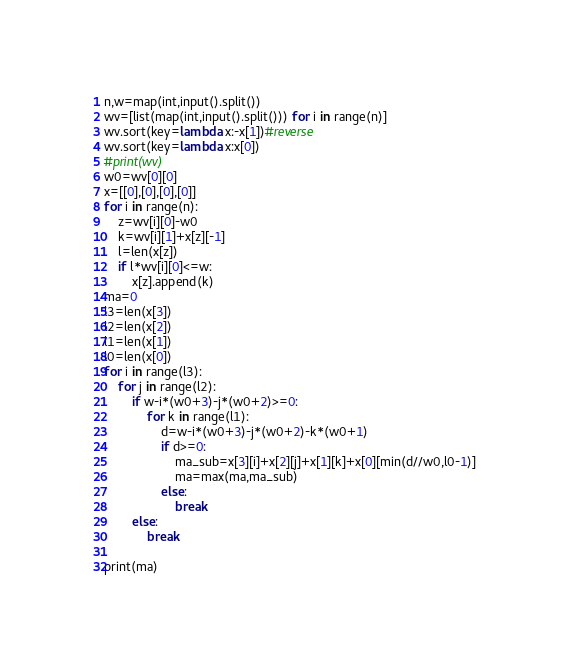<code> <loc_0><loc_0><loc_500><loc_500><_Python_>n,w=map(int,input().split())
wv=[list(map(int,input().split())) for i in range(n)]
wv.sort(key=lambda x:-x[1])#reverse
wv.sort(key=lambda x:x[0])
#print(wv)
w0=wv[0][0]
x=[[0],[0],[0],[0]]
for i in range(n):
    z=wv[i][0]-w0
    k=wv[i][1]+x[z][-1]
    l=len(x[z])
    if l*wv[i][0]<=w:
        x[z].append(k)
ma=0
l3=len(x[3])
l2=len(x[2])
l1=len(x[1])
l0=len(x[0])
for i in range(l3):
    for j in range(l2):
        if w-i*(w0+3)-j*(w0+2)>=0:
            for k in range(l1):
                d=w-i*(w0+3)-j*(w0+2)-k*(w0+1)
                if d>=0:
                    ma_sub=x[3][i]+x[2][j]+x[1][k]+x[0][min(d//w0,l0-1)]
                    ma=max(ma,ma_sub)
                else:
                    break
        else:
            break

print(ma)
</code> 